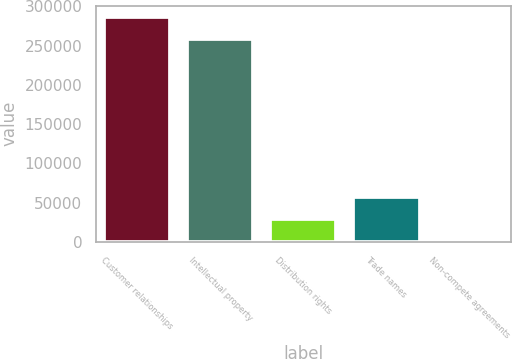Convert chart. <chart><loc_0><loc_0><loc_500><loc_500><bar_chart><fcel>Customer relationships<fcel>Intellectual property<fcel>Distribution rights<fcel>Trade names<fcel>Non-compete agreements<nl><fcel>286509<fcel>258580<fcel>29904.7<fcel>57833.4<fcel>1976<nl></chart> 